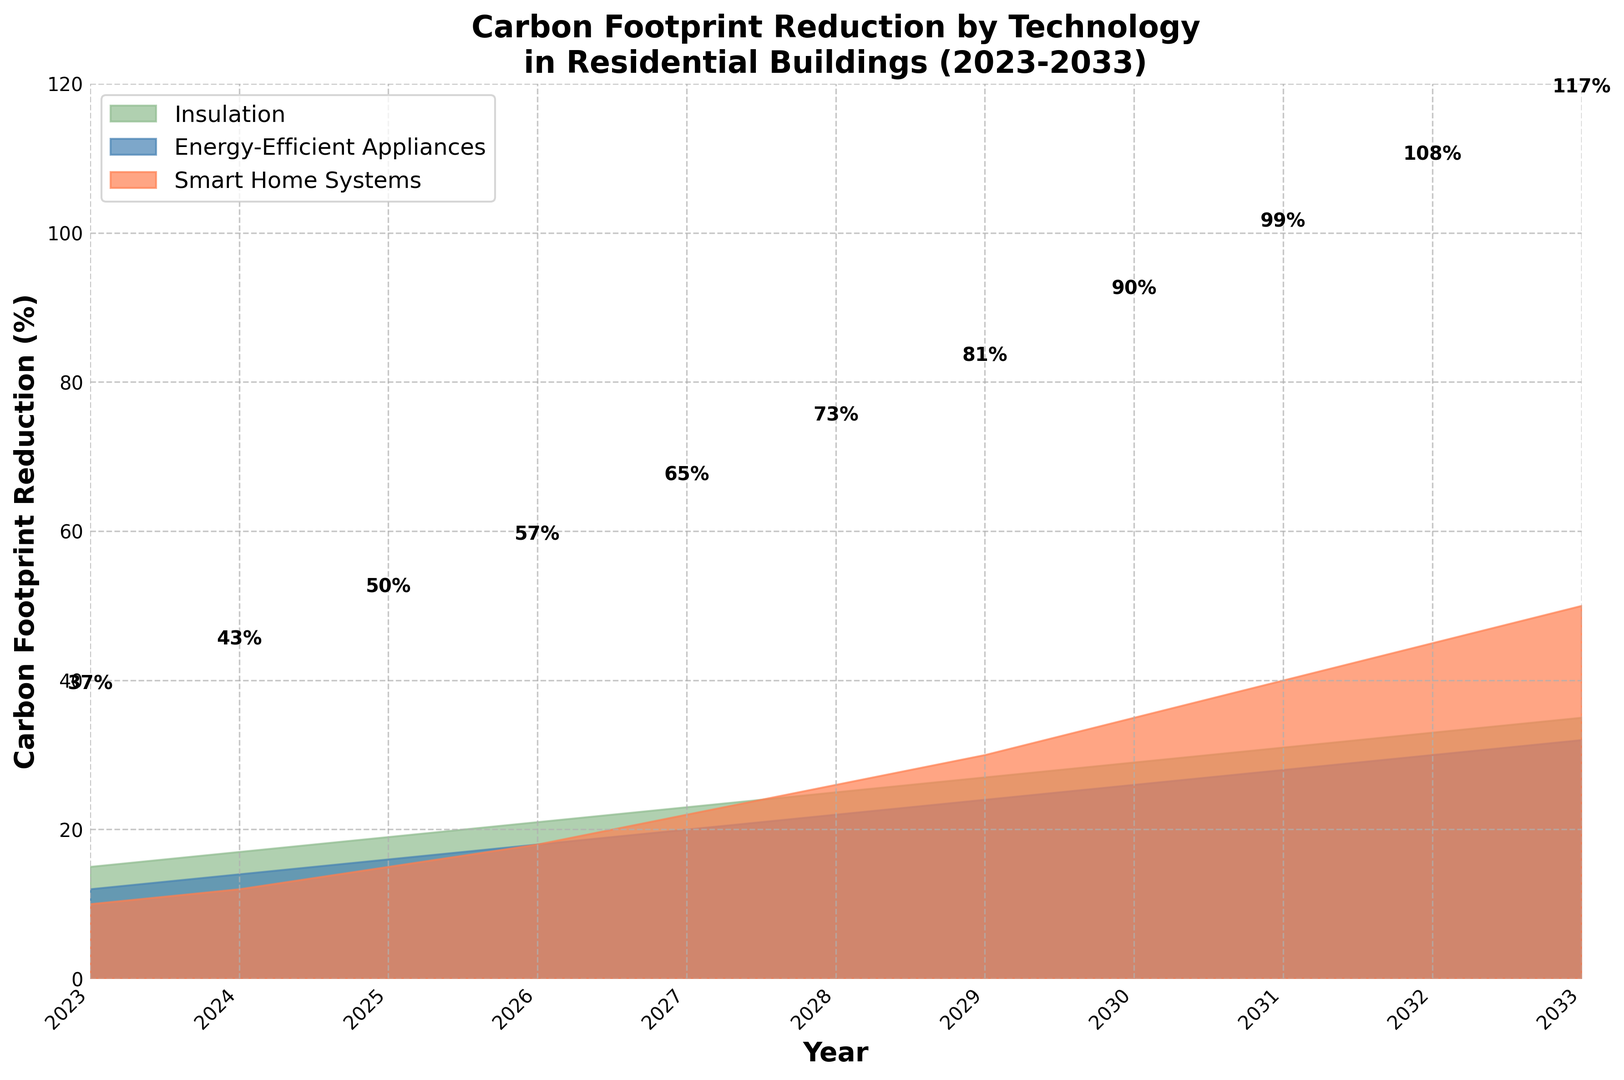What is the maximum carbon footprint reduction achieved in 2028, and through which technology? Look at the height of each section in the 2028 slot. Energy-efficient appliances reach the highest value at 22%.
Answer: Energy-efficient appliances, 22% Which technology has the highest cumulative carbon footprint reduction over the 10-year period? Sum the values for each technology from 2023 to 2033. Smart Home Systems: 10+12+15+18+22+26+30+35+40+45+50 = 303%, Energy-Efficient Appliances: 12+14+16+18+20+22+24+26+28+30+32 = 242%, Insulation: 15+17+19+21+23+25+27+29+31+33+35 = 275%, Smart Home Systems have the highest sum.
Answer: Smart Home Systems In which year does insulation contribute the largest portion of the total carbon footprint reduction? Compare the relative height of the green area for each year, accounting for the total height. In 2023, it is the highest relative to the other technologies.
Answer: 2023 What is the average annual carbon footprint reduction provided by smart home systems over the 10-year period? Calculate the average value of the smart home systems: (10 + 12 + 15 + 18 + 22 + 26 + 30 + 35 + 40 + 45 + 50) / 11 = 303 / 11.
Answer: 27.5% In 2030, how does the carbon footprint reduction from insulation compare with that from energy-efficient appliances? For 2030, insulation is at 29% and energy-efficient appliances at 26%, so insulation is larger.
Answer: Insulation is larger by 3% How much more does insulation reduce the carbon footprint compared to smart home systems in 2025? Subtract the percentage of smart home systems from that of insulation: 19% (insulation) - 15% (smart home systems).
Answer: 4% Which year shows the steepest increase in total carbon footprint reduction from the previous year, and what is the increase? Calculate the year-to-year differences for total reduction: e.g., 2024 (12+14+17) - 2023 (10+12+15) = 43-37 = 6, compare for all years. The steepest increase is between 2031 and 2032 (30+28+40) - (26+24+35) = 103 - 85 = 18.
Answer: 2031 to 2032, 18% What are the individual contributions of each technology to the total carbon footprint reduction in 2033? Look at the percentages for 2033: Smart Home Systems: 50%, Energy-Efficient Appliances: 32%, Insulation: 35%. Add these up: 50+32+35 = 117% total.
Answer: Smart Home Systems: 50%, Energy-Efficient Appliances: 32%, Insulation: 35% In which year do smart home systems surpass energy-efficient appliances in terms of carbon footprint reduction for the first time? Compare the values of smart home systems and energy-efficient appliances for each year. Smart home systems first surpass energy-efficient appliances in 2029 (30% vs 24%).
Answer: 2029 What is the combined carbon footprint reduction from energy-efficient appliances and insulation in 2027? Add the contributions from both technologies in 2027: 23% (insulation) + 20% (energy-efficient appliances).
Answer: 43% 